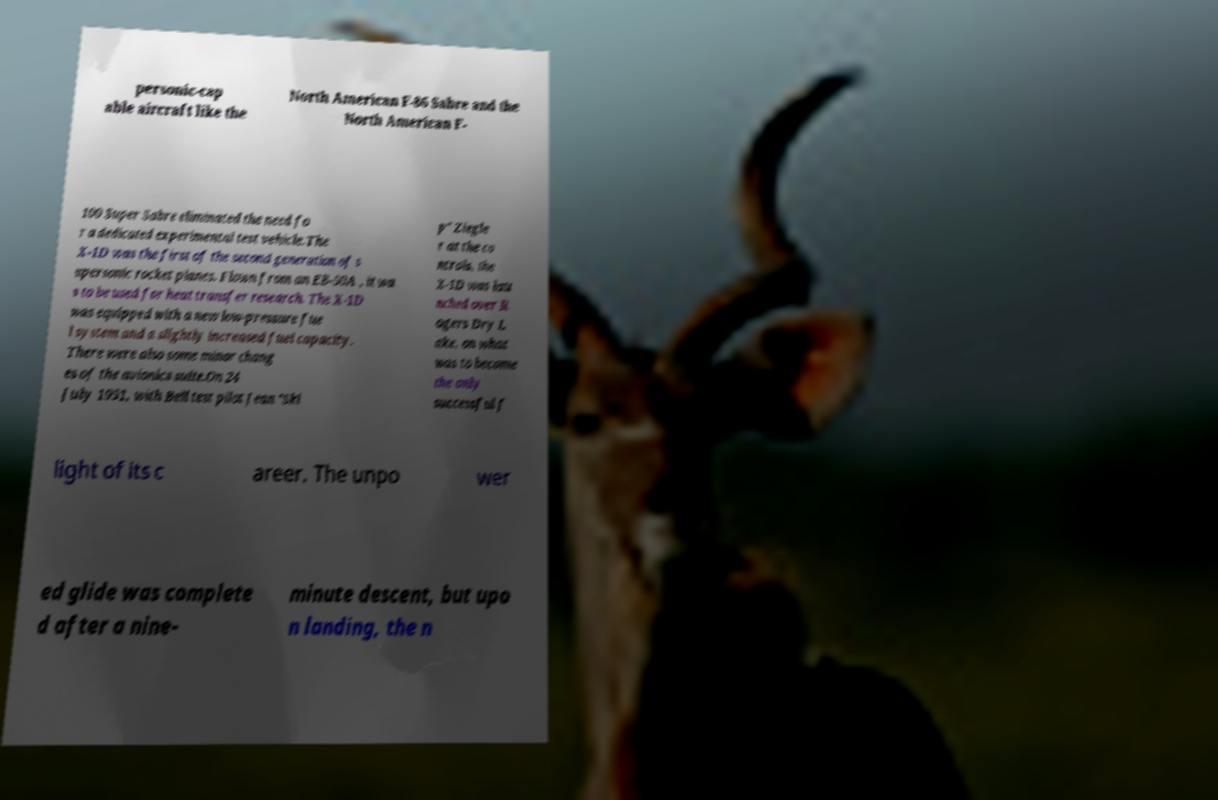Please identify and transcribe the text found in this image. personic-cap able aircraft like the North American F-86 Sabre and the North American F- 100 Super Sabre eliminated the need fo r a dedicated experimental test vehicle.The X-1D was the first of the second generation of s upersonic rocket planes. Flown from an EB-50A , it wa s to be used for heat transfer research. The X-1D was equipped with a new low-pressure fue l system and a slightly increased fuel capacity. There were also some minor chang es of the avionics suite.On 24 July 1951, with Bell test pilot Jean "Ski p" Ziegle r at the co ntrols, the X-1D was lau nched over R ogers Dry L ake, on what was to become the only successful f light of its c areer. The unpo wer ed glide was complete d after a nine- minute descent, but upo n landing, the n 